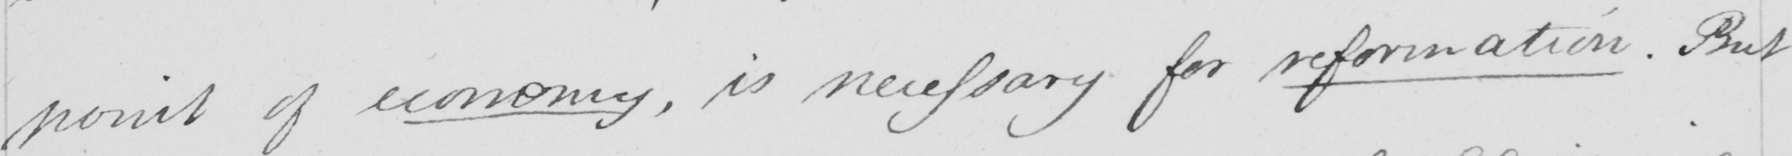Transcribe the text shown in this historical manuscript line. point of economy , is necessary for reformation . But 